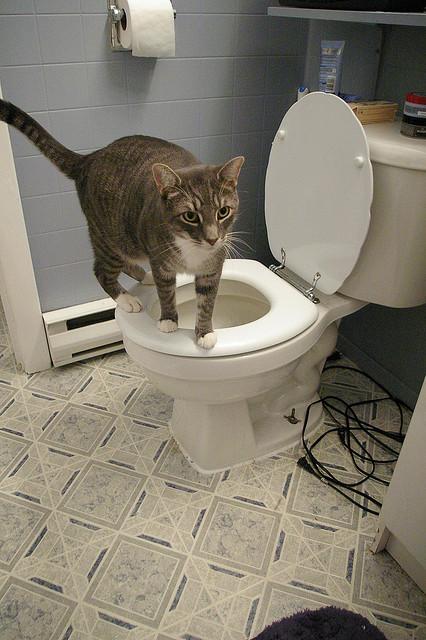What small appliances do the cords most likely belong to?
Answer briefly. Hair dryer. What is the cat doing?
Keep it brief. Standing on toilet. What color are the tiles?
Keep it brief. White. Is the toilet paper going over or under?
Concise answer only. Over. 